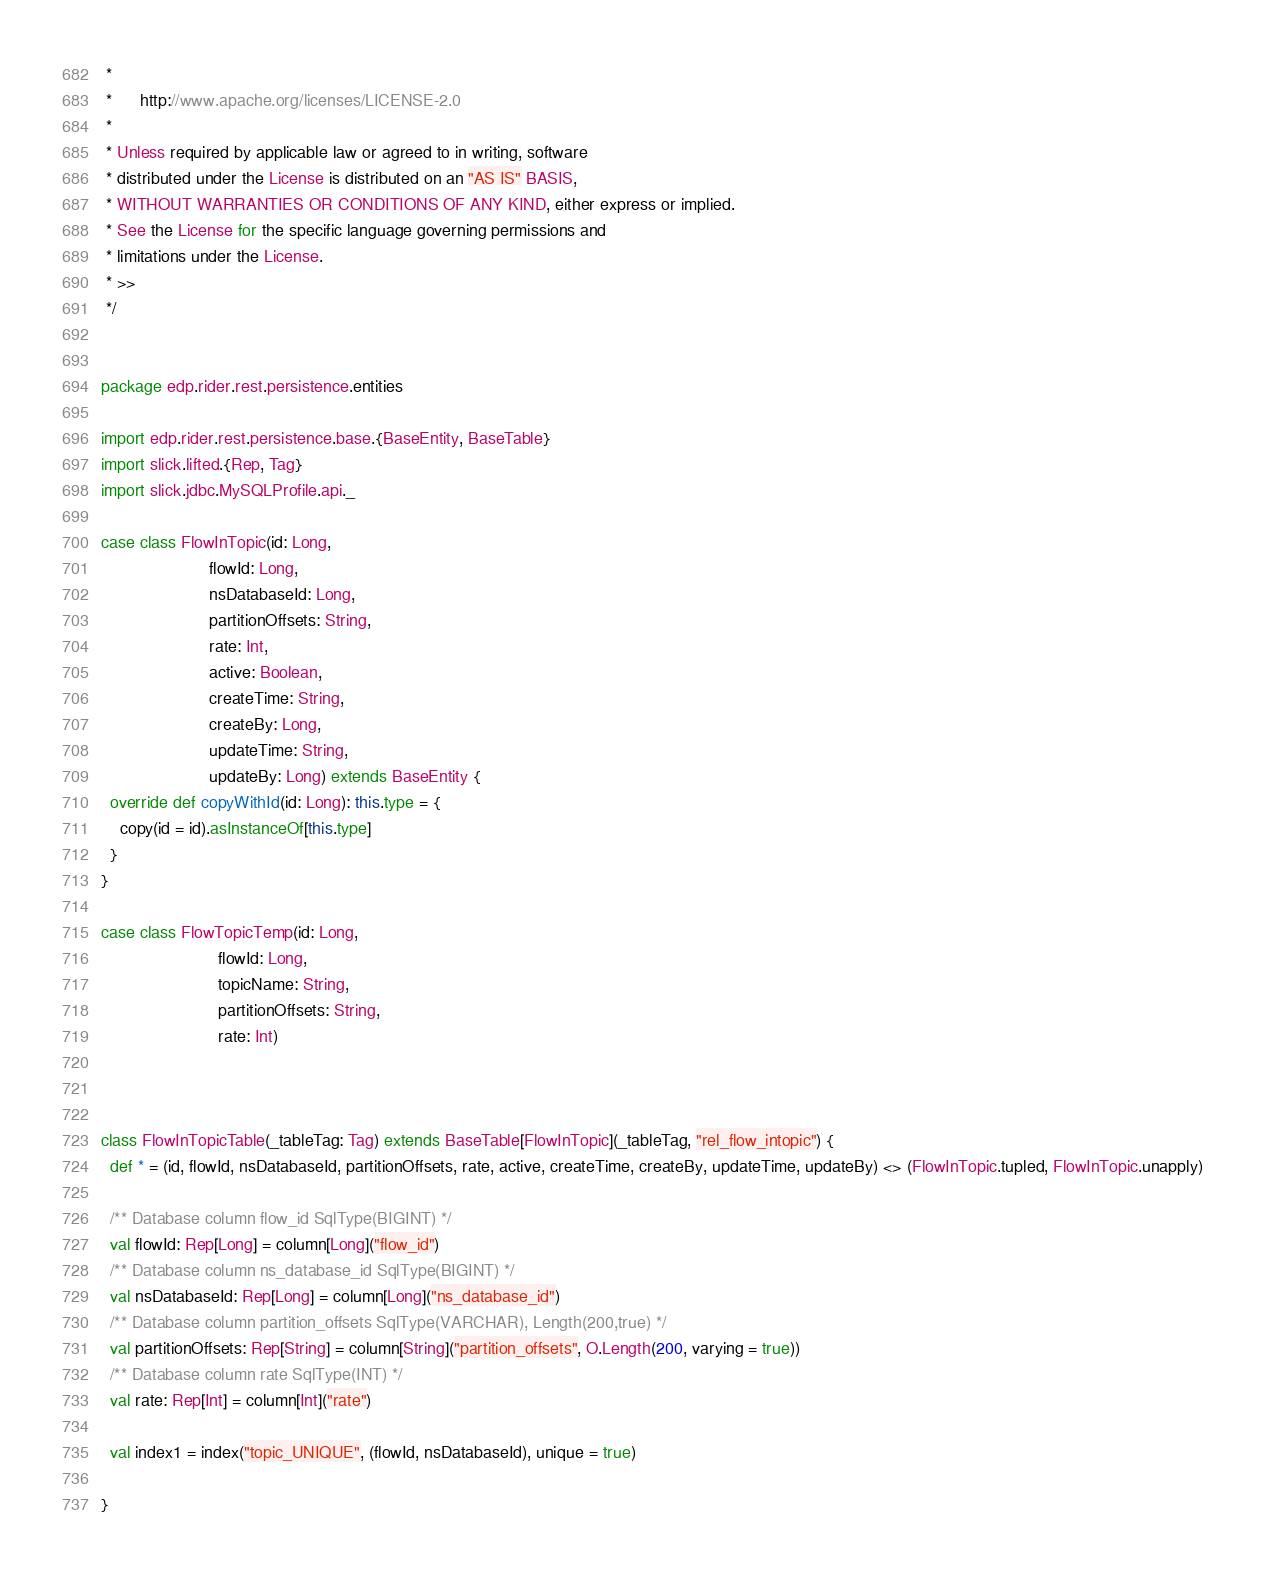<code> <loc_0><loc_0><loc_500><loc_500><_Scala_> *
 *      http://www.apache.org/licenses/LICENSE-2.0
 *
 * Unless required by applicable law or agreed to in writing, software
 * distributed under the License is distributed on an "AS IS" BASIS,
 * WITHOUT WARRANTIES OR CONDITIONS OF ANY KIND, either express or implied.
 * See the License for the specific language governing permissions and
 * limitations under the License.
 * >>
 */


package edp.rider.rest.persistence.entities

import edp.rider.rest.persistence.base.{BaseEntity, BaseTable}
import slick.lifted.{Rep, Tag}
import slick.jdbc.MySQLProfile.api._

case class FlowInTopic(id: Long,
                       flowId: Long,
                       nsDatabaseId: Long,
                       partitionOffsets: String,
                       rate: Int,
                       active: Boolean,
                       createTime: String,
                       createBy: Long,
                       updateTime: String,
                       updateBy: Long) extends BaseEntity {
  override def copyWithId(id: Long): this.type = {
    copy(id = id).asInstanceOf[this.type]
  }
}

case class FlowTopicTemp(id: Long,
                         flowId: Long,
                         topicName: String,
                         partitionOffsets: String,
                         rate: Int)



class FlowInTopicTable(_tableTag: Tag) extends BaseTable[FlowInTopic](_tableTag, "rel_flow_intopic") {
  def * = (id, flowId, nsDatabaseId, partitionOffsets, rate, active, createTime, createBy, updateTime, updateBy) <> (FlowInTopic.tupled, FlowInTopic.unapply)

  /** Database column flow_id SqlType(BIGINT) */
  val flowId: Rep[Long] = column[Long]("flow_id")
  /** Database column ns_database_id SqlType(BIGINT) */
  val nsDatabaseId: Rep[Long] = column[Long]("ns_database_id")
  /** Database column partition_offsets SqlType(VARCHAR), Length(200,true) */
  val partitionOffsets: Rep[String] = column[String]("partition_offsets", O.Length(200, varying = true))
  /** Database column rate SqlType(INT) */
  val rate: Rep[Int] = column[Int]("rate")

  val index1 = index("topic_UNIQUE", (flowId, nsDatabaseId), unique = true)

}
</code> 